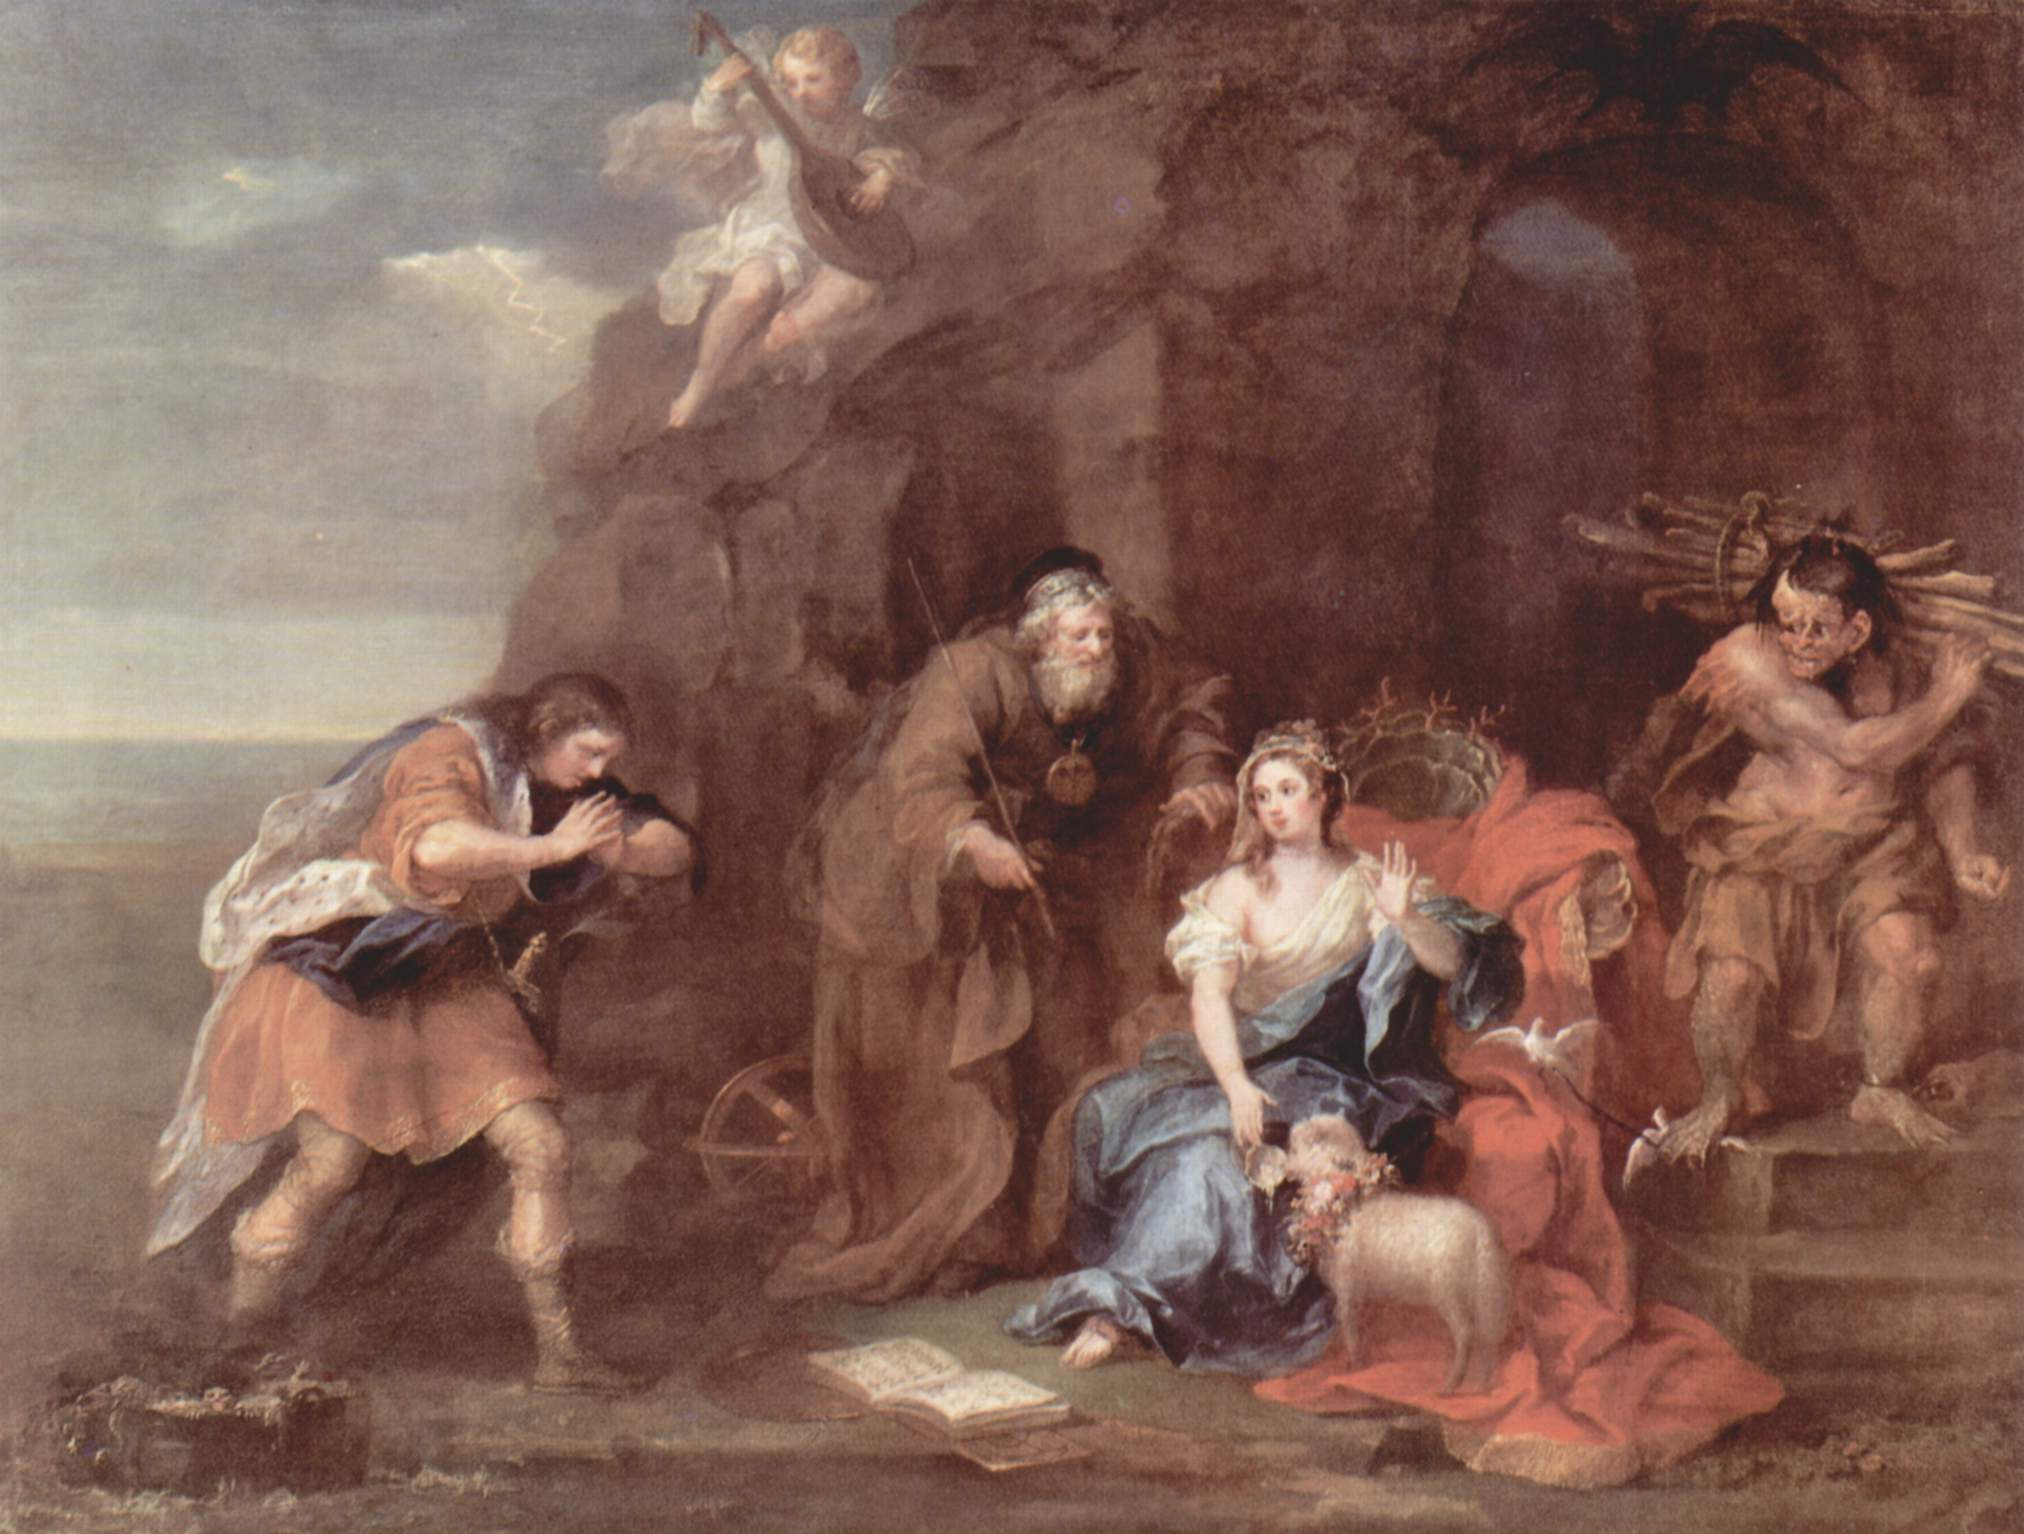What kind of mythological or allegorical themes can you infer from this painting? From the painting, several mythological and allegorical themes emerge. The reclining woman in blue evokes the image of a muse or a goddess of wisdom, guiding and inspiring those around her. Her book symbolizes the pursuit of knowledge and enlightenment. The attending man in the brown robe may represent devotion or scholarly diligence, embodying the dedication needed to acquire wisdom.

The cherubs holding a garland of flowers suggest themes of divine blessing, festivity, and innocence. Cherubs are often messengers of the gods, and their presence here could signify heavenly approval or joy.

The man playing the flute introduces a pastoral element, emblematic of harmony with nature and the arts, crucial themes in both mythological and allegorical contexts.

The rugged figure carrying wood in the background might represent labor or the burdens of life, a stark contrast to the serenity of the central figures, thus highlighting the dualities of existence—knowledge versus ignorance, peace versus struggle, the divine versus the mundane.

Overall, the painting communicates the harmonized coexistence of these various elements, illustrating a balanced and prosperous world where knowledge, art, and divine favor interlace seamlessly. 